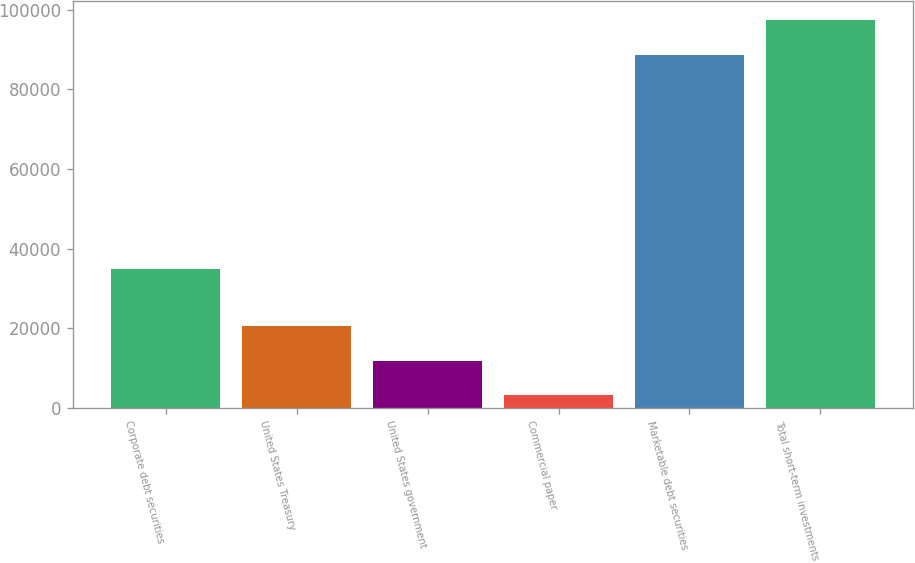Convert chart. <chart><loc_0><loc_0><loc_500><loc_500><bar_chart><fcel>Corporate debt securities<fcel>United States Treasury<fcel>United States government<fcel>Commercial paper<fcel>Marketable debt securities<fcel>Total short-term investments<nl><fcel>34919<fcel>20628<fcel>11906<fcel>3184<fcel>88587<fcel>97309<nl></chart> 